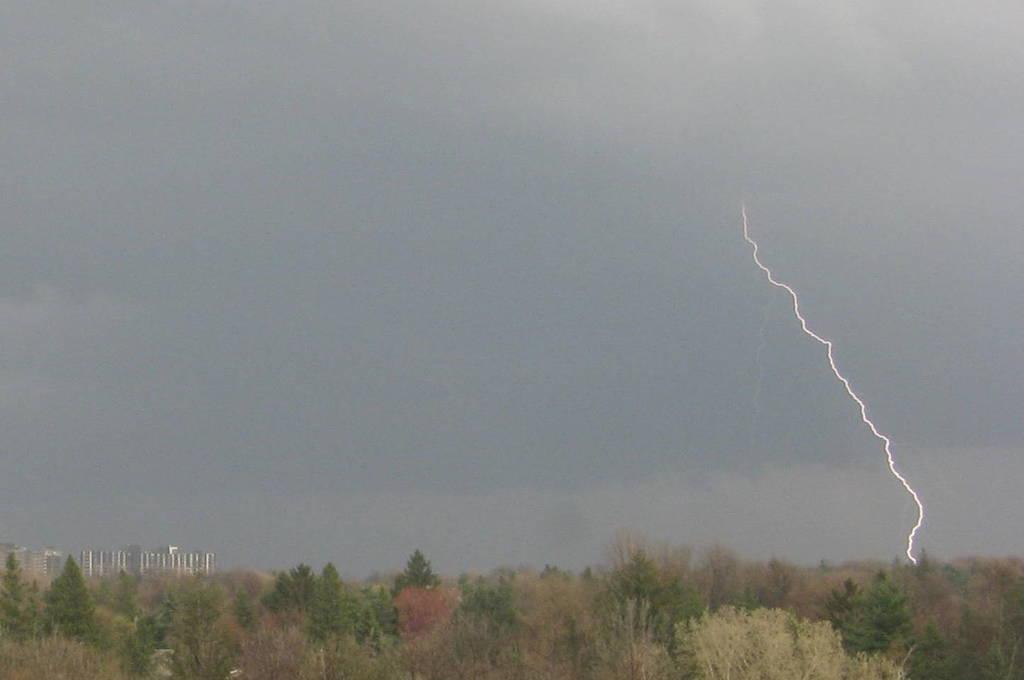How would you summarize this image in a sentence or two? At the bottom there are trees and buildings. At the top we can see sky, sky is cloudy. 